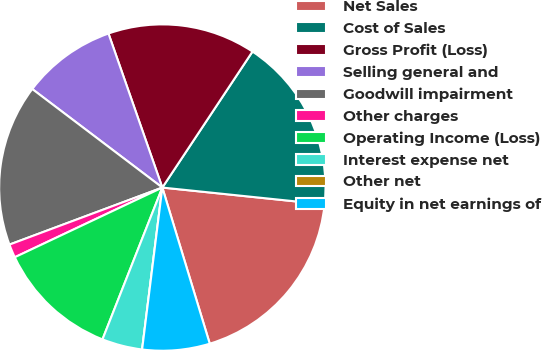Convert chart. <chart><loc_0><loc_0><loc_500><loc_500><pie_chart><fcel>Net Sales<fcel>Cost of Sales<fcel>Gross Profit (Loss)<fcel>Selling general and<fcel>Goodwill impairment<fcel>Other charges<fcel>Operating Income (Loss)<fcel>Interest expense net<fcel>Other net<fcel>Equity in net earnings of<nl><fcel>18.66%<fcel>17.33%<fcel>14.67%<fcel>9.33%<fcel>16.0%<fcel>1.34%<fcel>12.0%<fcel>4.0%<fcel>0.0%<fcel>6.67%<nl></chart> 